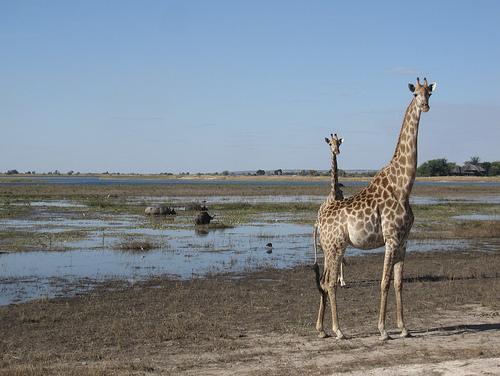How many giraffe are there?
Give a very brief answer. 2. 